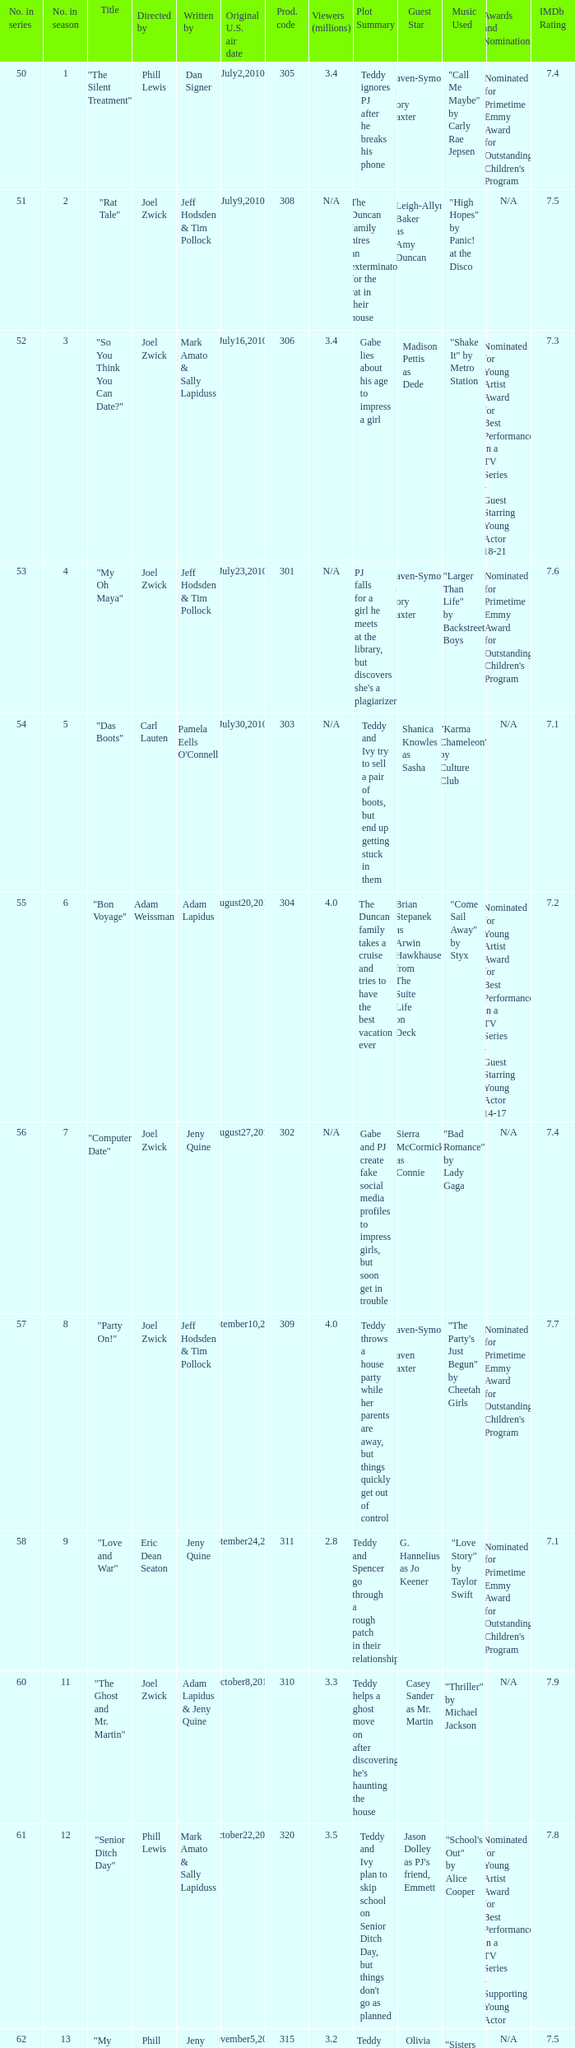What is the count of million viewers who saw episode 6? 4.0. 